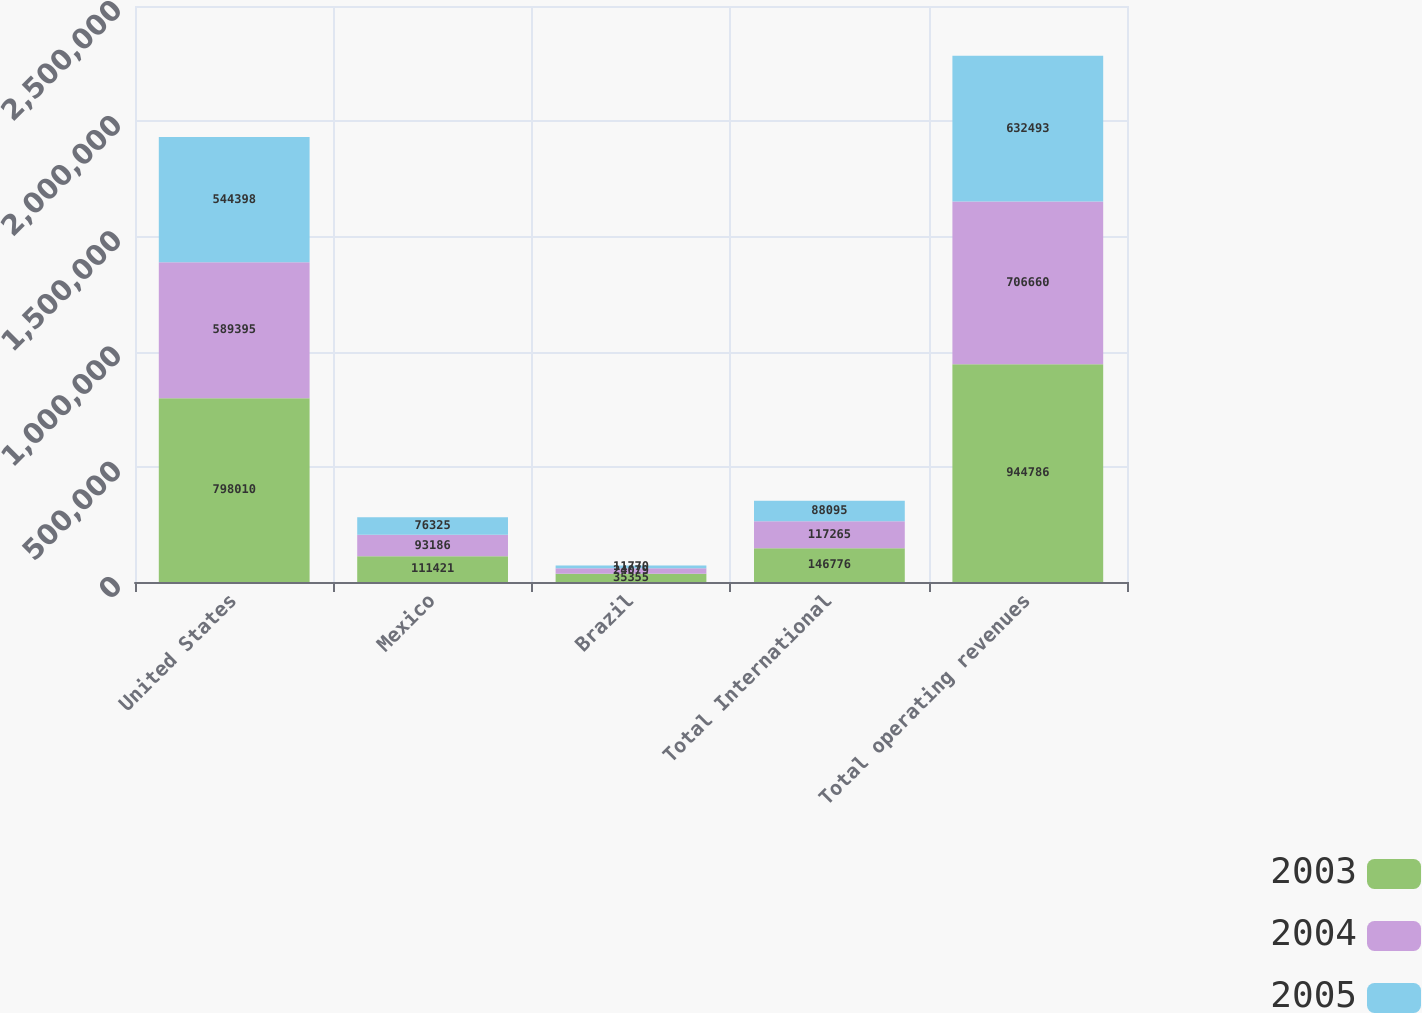<chart> <loc_0><loc_0><loc_500><loc_500><stacked_bar_chart><ecel><fcel>United States<fcel>Mexico<fcel>Brazil<fcel>Total International<fcel>Total operating revenues<nl><fcel>2003<fcel>798010<fcel>111421<fcel>35355<fcel>146776<fcel>944786<nl><fcel>2004<fcel>589395<fcel>93186<fcel>24079<fcel>117265<fcel>706660<nl><fcel>2005<fcel>544398<fcel>76325<fcel>11770<fcel>88095<fcel>632493<nl></chart> 